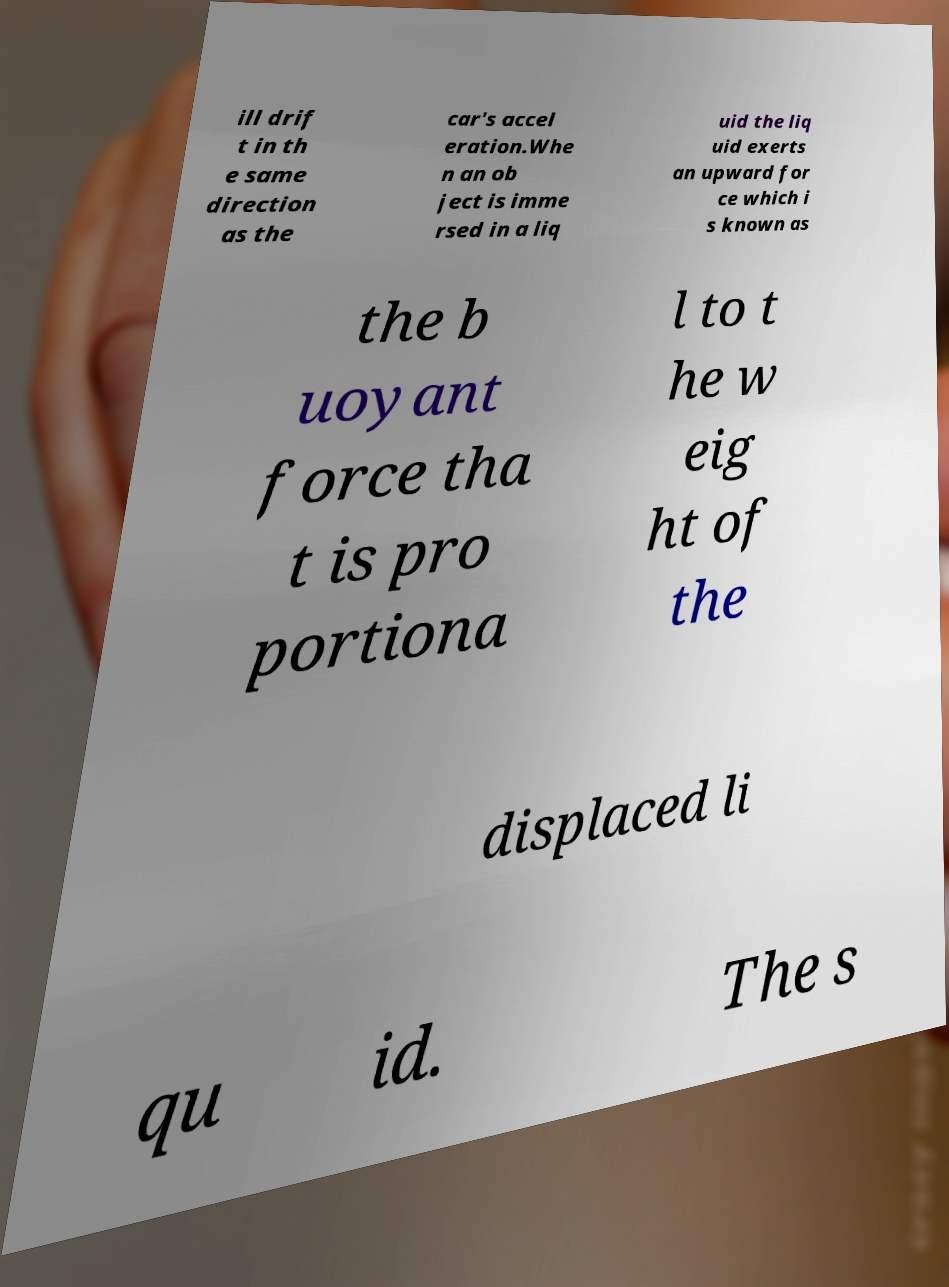Can you accurately transcribe the text from the provided image for me? ill drif t in th e same direction as the car's accel eration.Whe n an ob ject is imme rsed in a liq uid the liq uid exerts an upward for ce which i s known as the b uoyant force tha t is pro portiona l to t he w eig ht of the displaced li qu id. The s 